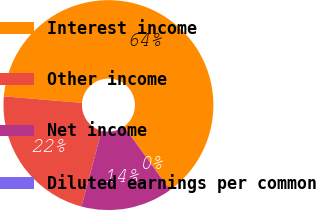Convert chart to OTSL. <chart><loc_0><loc_0><loc_500><loc_500><pie_chart><fcel>Interest income<fcel>Other income<fcel>Net income<fcel>Diluted earnings per common<nl><fcel>63.68%<fcel>22.2%<fcel>14.11%<fcel>0.0%<nl></chart> 